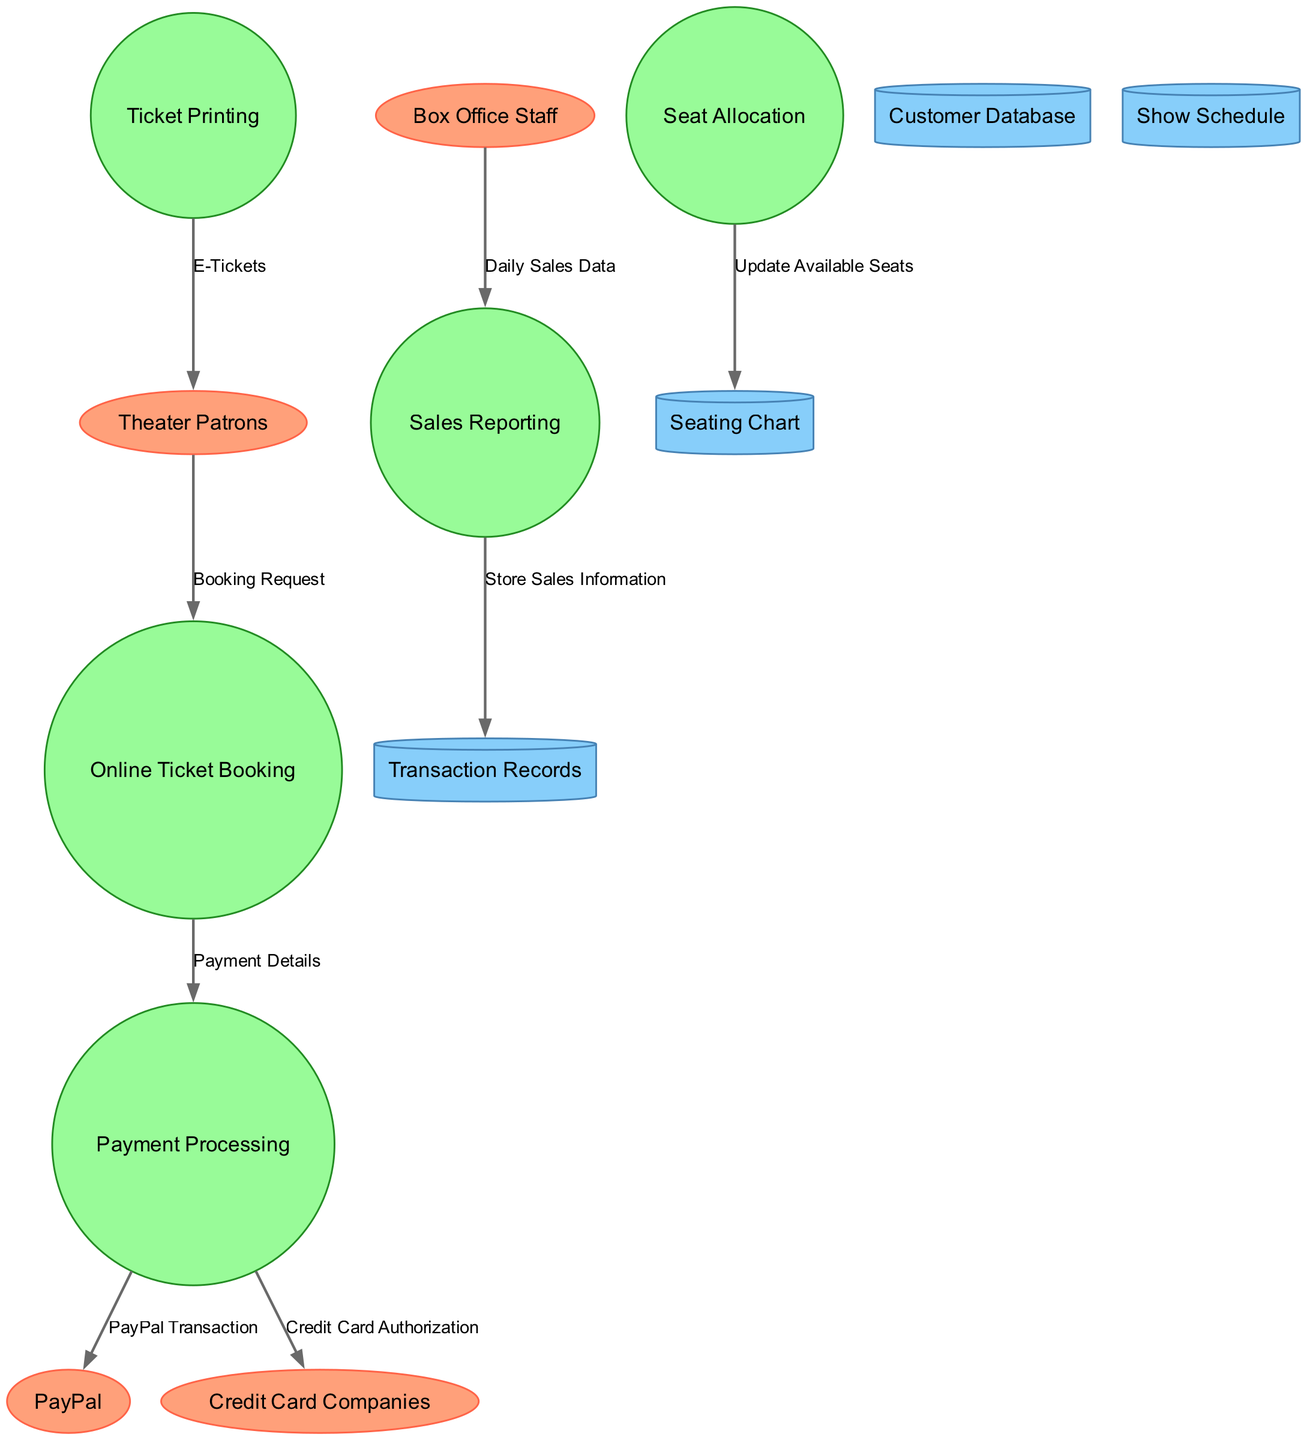What are the external entities in the diagram? The external entities listed in the diagram are Theater Patrons, PayPal, Credit Card Companies, and Box Office Staff. This information can be directly identified from the external entities section at the top of the diagram.
Answer: Theater Patrons, PayPal, Credit Card Companies, Box Office Staff How many processes are in the diagram? Counting the processes presented in the diagram, which are Online Ticket Booking, Payment Processing, Seat Allocation, Ticket Printing, and Sales Reporting, gives us a total of five processes. This is easily observed by looking at the number of process nodes.
Answer: 5 What is the data flow from Payment Processing to PayPal? The label on the data flow from Payment Processing to PayPal is "PayPal Transaction." This can be directly identified by tracing the edge in the diagram connecting these two nodes.
Answer: PayPal Transaction Which process updates the available seats? The process labeled "Seat Allocation" is responsible for updating the available seats, as indicated by the data flow that goes from Seat Allocation to the Seating Chart.
Answer: Seat Allocation What data store receives information from Sales Reporting? The data from Sales Reporting is stored in "Transaction Records" as shown by the edge linking Sales Reporting to Transaction Records with the label "Store Sales Information." This relationship can be traced in the diagram.
Answer: Transaction Records What is the relationship between Box Office Staff and Sales Reporting? The relationship is that Box Office Staff provides "Daily Sales Data" to the Sales Reporting process. This is demonstrated by the data flow direction from Box Office Staff to Sales Reporting in the diagram.
Answer: Daily Sales Data Which entities are involved in payment processing? The entities involved in payment processing are PayPal and Credit Card Companies, based on the data flows originating from the Payment Processing process to each entity.
Answer: PayPal, Credit Card Companies How does the Ticket Printing process communicate with Theater Patrons? The Ticket Printing process communicates with Theater Patrons by providing "E-Tickets" as per the data flow shown in the diagram from Ticket Printing to Theater Patrons.
Answer: E-Tickets 